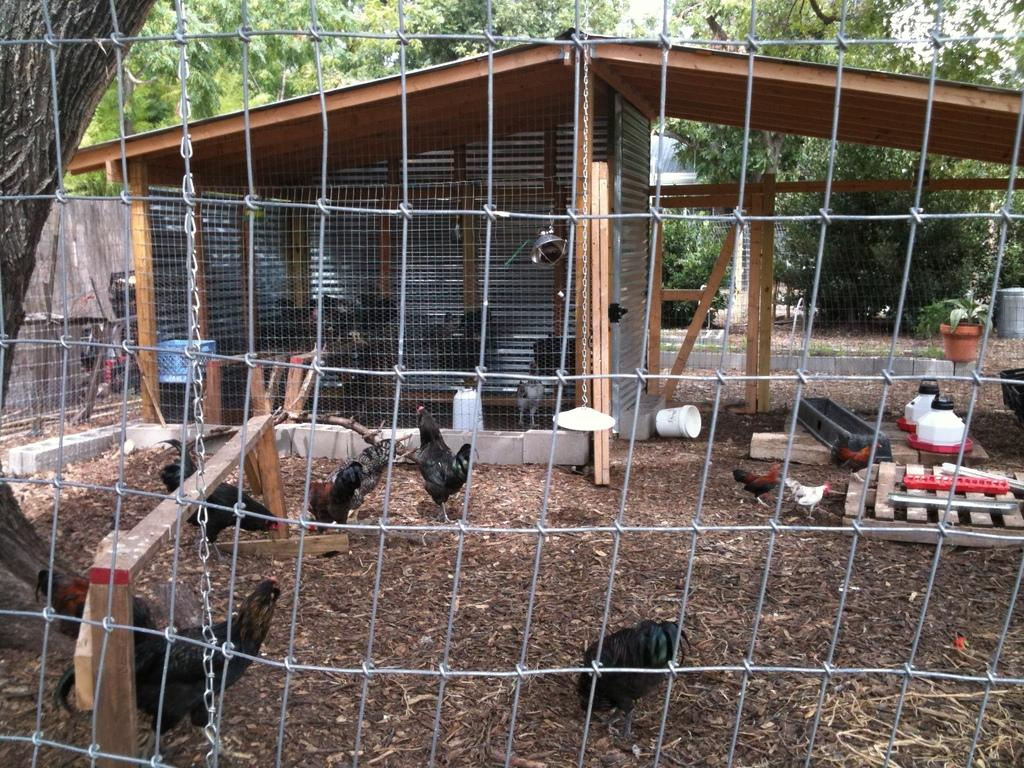What type of animals can be seen in the image? There are hens in the image. What type of structure is present in the image? There is a shed in the image. What type of enclosure is visible in the image? There is fencing in the image. What type of object is attached to the chain in the image? The chain is attached to a plate in the image. What type of vegetation is present in the image? There are trees and plants in the image. What type of support structure is present in the image? There are wooden poles in the image. What type of object is present in the image that might be used for storage? There are cans in the image. What type of barrier is present in the image? There is a wall in the image. What type of beef is being cooked in the kettle in the image? There is no kettle or beef present in the image. 